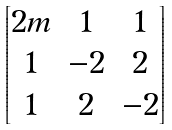<formula> <loc_0><loc_0><loc_500><loc_500>\begin{bmatrix} 2 m & 1 & 1 \\ 1 & - 2 & 2 \\ 1 & 2 & - 2 \end{bmatrix}</formula> 